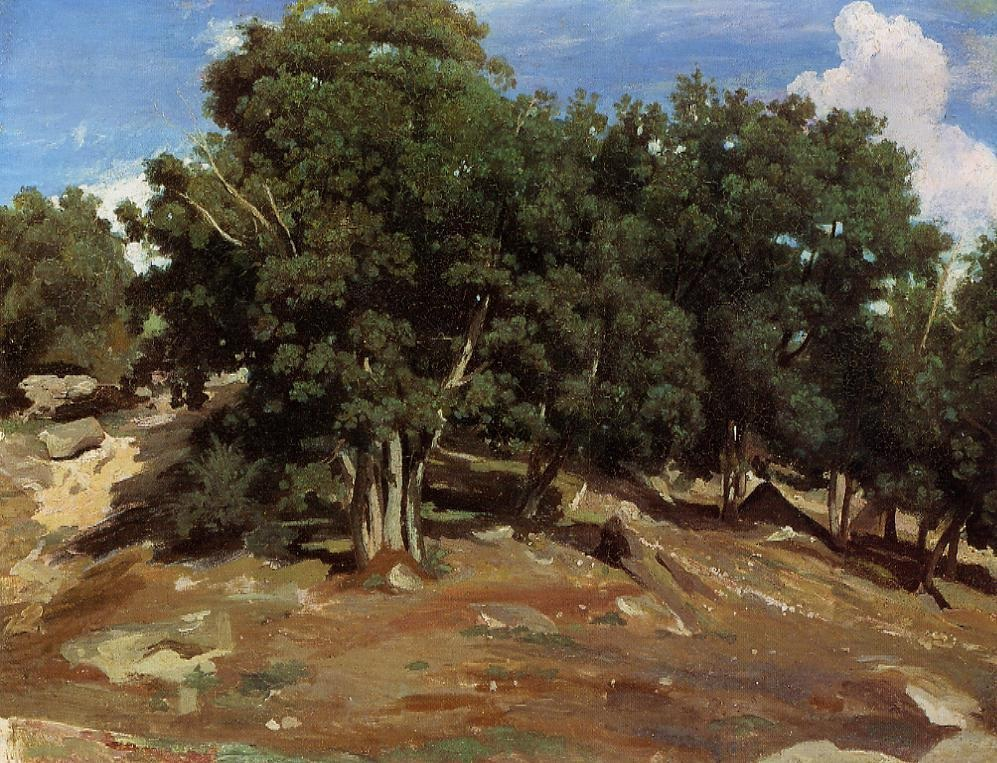If you could transform this landscape into a magical forest, what fantastical elements would you add? In transforming this landscape into a magical forest, I would add shimmering, bioluminescent plants that glow with soft, ethereal light during the night, creating an enchanting atmosphere. Wisps, small glowing spirits, would dance gracefully among the trees, leaving trails of sparkling light in their wake. The trees themselves would be ancient and wise, with faces appearing in their bark, whispering ancient secrets to those who listen closely. A gentle, enchanted river would wind through the hillside, its waters sparkling under the light, with mythical creatures like fairies and majestic unicorns coming to drink. This transformed landscape would be a haven of magic and wonder, where every rock and leaf holds a story waiting to be discovered. 